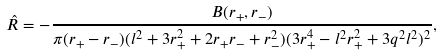Convert formula to latex. <formula><loc_0><loc_0><loc_500><loc_500>\hat { R } = - \frac { B ( r _ { + } , r _ { - } ) } { \pi ( r _ { + } - r _ { - } ) ( l ^ { 2 } + 3 r _ { + } ^ { 2 } + 2 r _ { + } r _ { - } + r _ { - } ^ { 2 } ) ( 3 r _ { + } ^ { 4 } - l ^ { 2 } r _ { + } ^ { 2 } + 3 q ^ { 2 } l ^ { 2 } ) ^ { 2 } } ,</formula> 